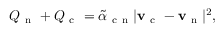<formula> <loc_0><loc_0><loc_500><loc_500>Q _ { n } + Q _ { c } = \tilde { \alpha } _ { c n } | v _ { c } - v _ { n } | ^ { 2 } ,</formula> 